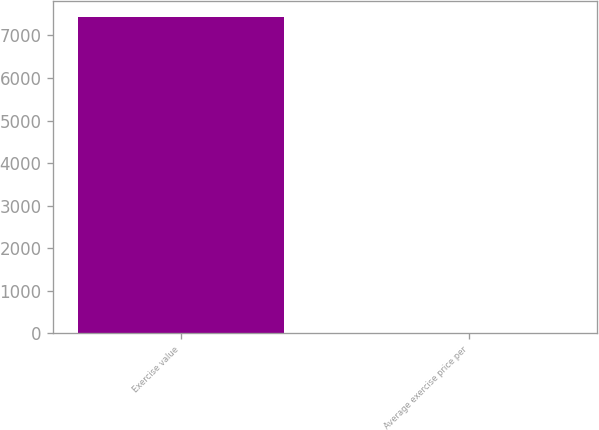<chart> <loc_0><loc_0><loc_500><loc_500><bar_chart><fcel>Exercise value<fcel>Average exercise price per<nl><fcel>7428<fcel>18.07<nl></chart> 